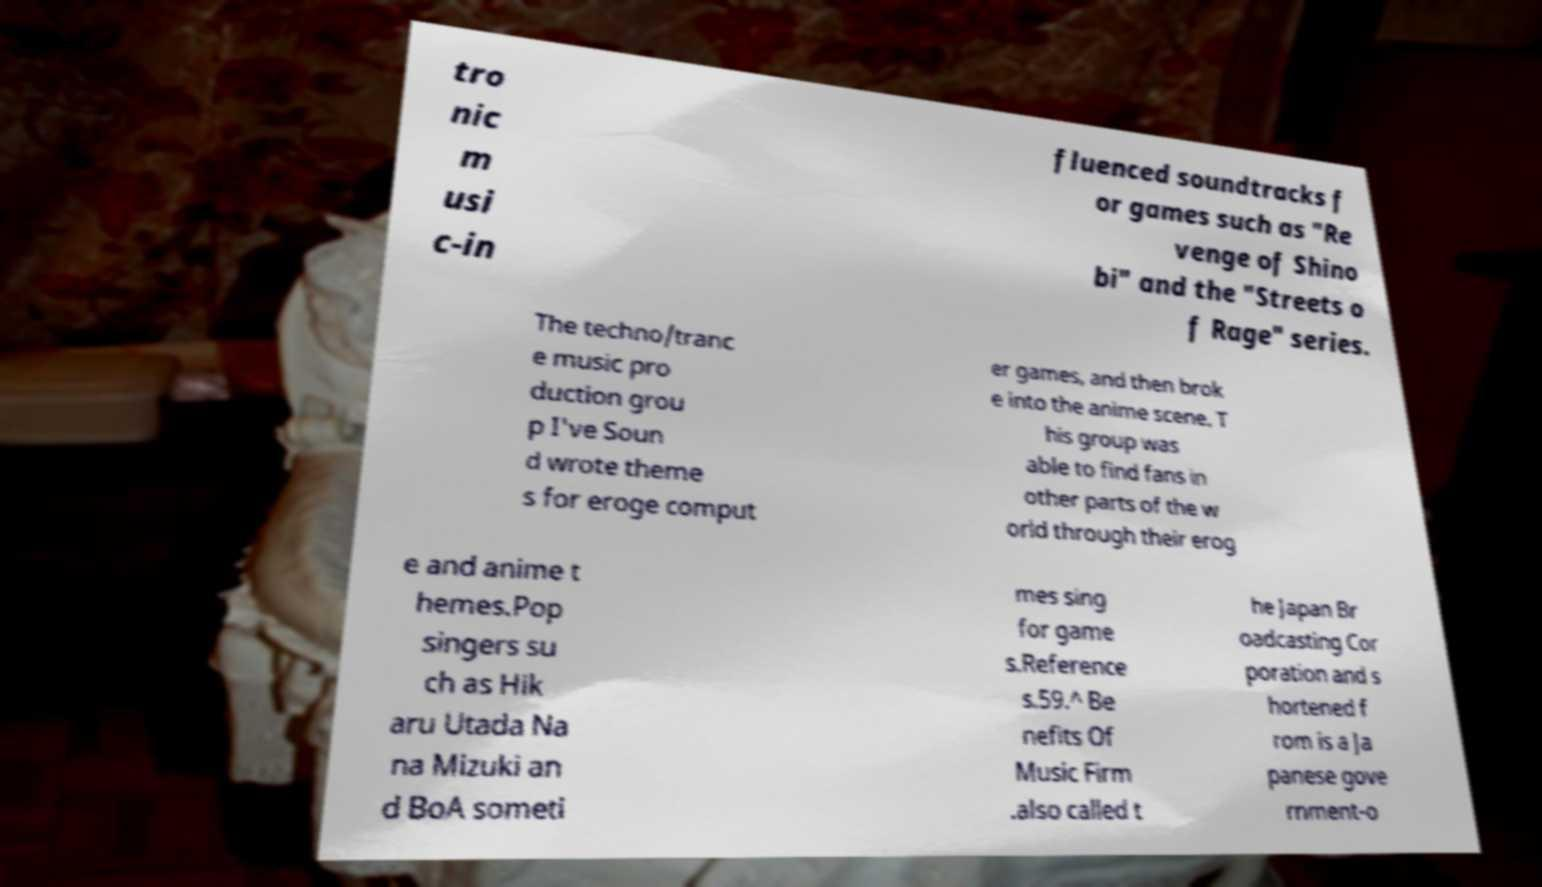What messages or text are displayed in this image? I need them in a readable, typed format. tro nic m usi c-in fluenced soundtracks f or games such as "Re venge of Shino bi" and the "Streets o f Rage" series. The techno/tranc e music pro duction grou p I've Soun d wrote theme s for eroge comput er games, and then brok e into the anime scene. T his group was able to find fans in other parts of the w orld through their erog e and anime t hemes.Pop singers su ch as Hik aru Utada Na na Mizuki an d BoA someti mes sing for game s.Reference s.59.^ Be nefits Of Music Firm .also called t he Japan Br oadcasting Cor poration and s hortened f rom is a Ja panese gove rnment-o 